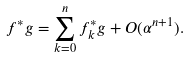Convert formula to latex. <formula><loc_0><loc_0><loc_500><loc_500>f ^ { * } g = \sum _ { k = 0 } ^ { n } f ^ { * } _ { k } g + O ( \alpha ^ { n + 1 } ) .</formula> 